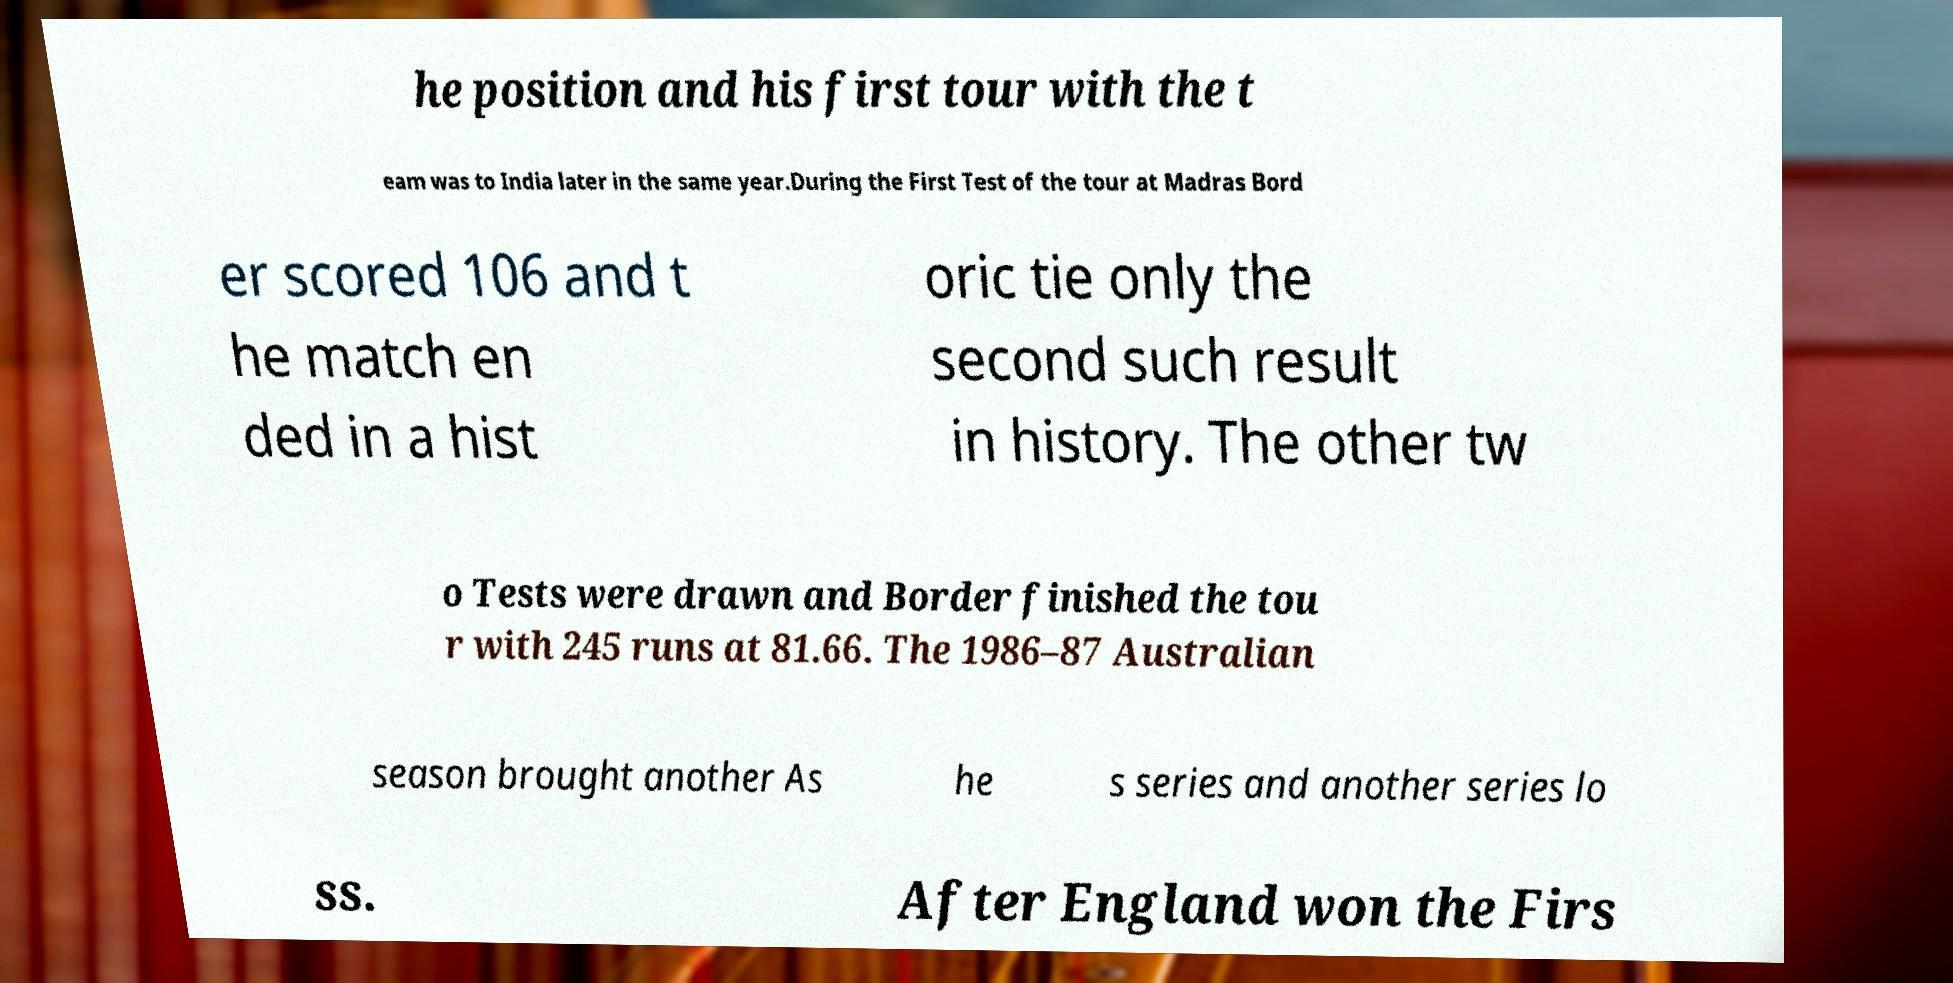For documentation purposes, I need the text within this image transcribed. Could you provide that? he position and his first tour with the t eam was to India later in the same year.During the First Test of the tour at Madras Bord er scored 106 and t he match en ded in a hist oric tie only the second such result in history. The other tw o Tests were drawn and Border finished the tou r with 245 runs at 81.66. The 1986–87 Australian season brought another As he s series and another series lo ss. After England won the Firs 